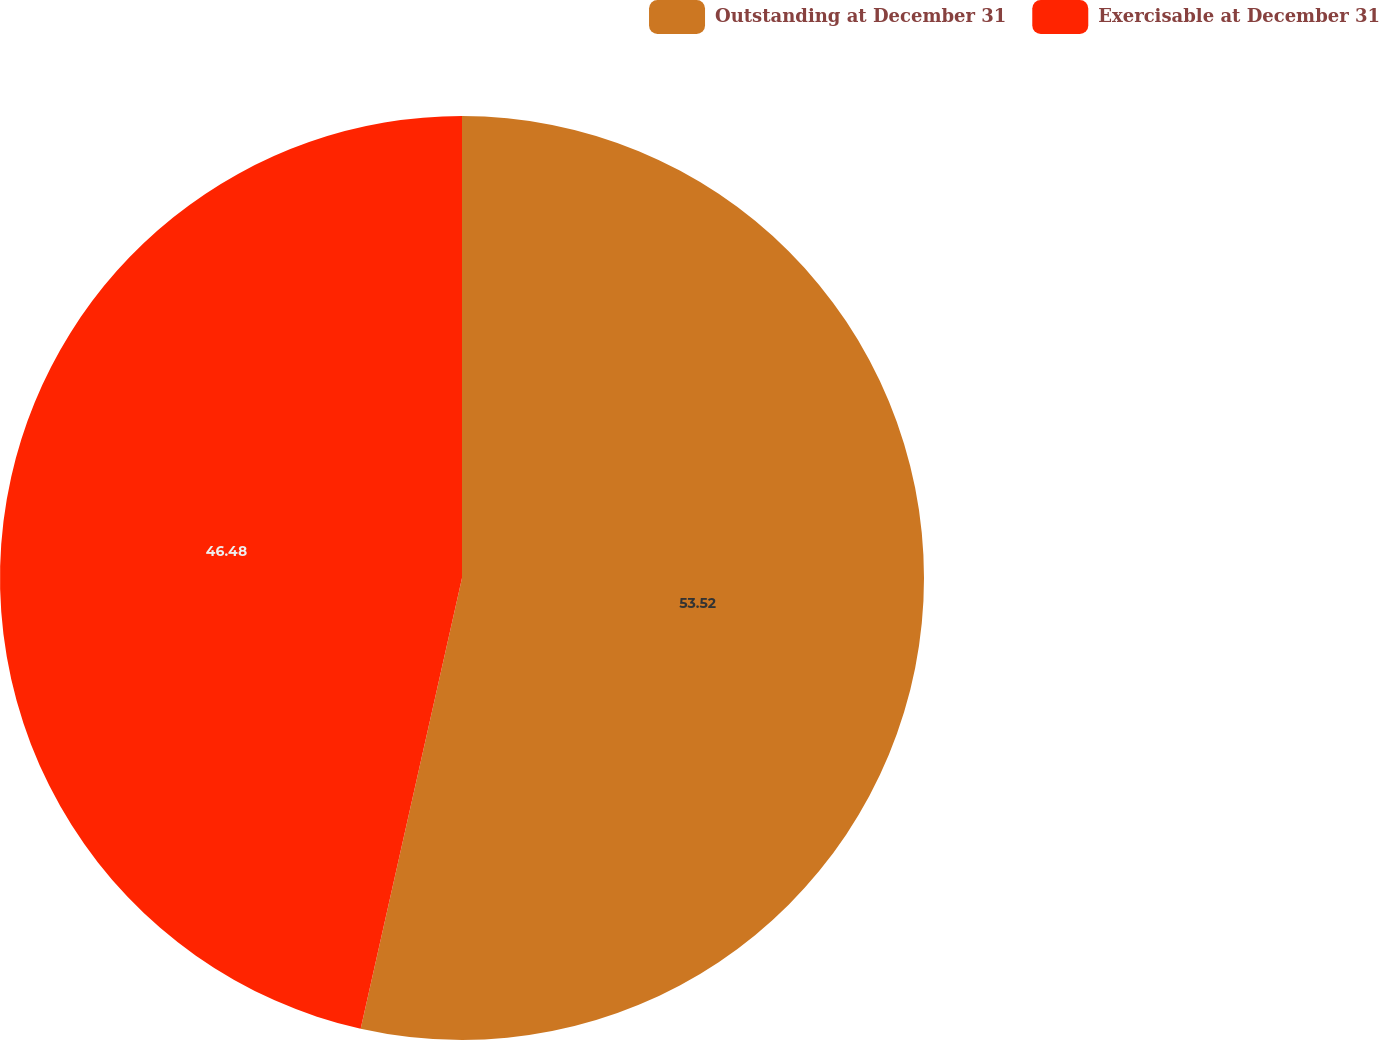Convert chart. <chart><loc_0><loc_0><loc_500><loc_500><pie_chart><fcel>Outstanding at December 31<fcel>Exercisable at December 31<nl><fcel>53.52%<fcel>46.48%<nl></chart> 